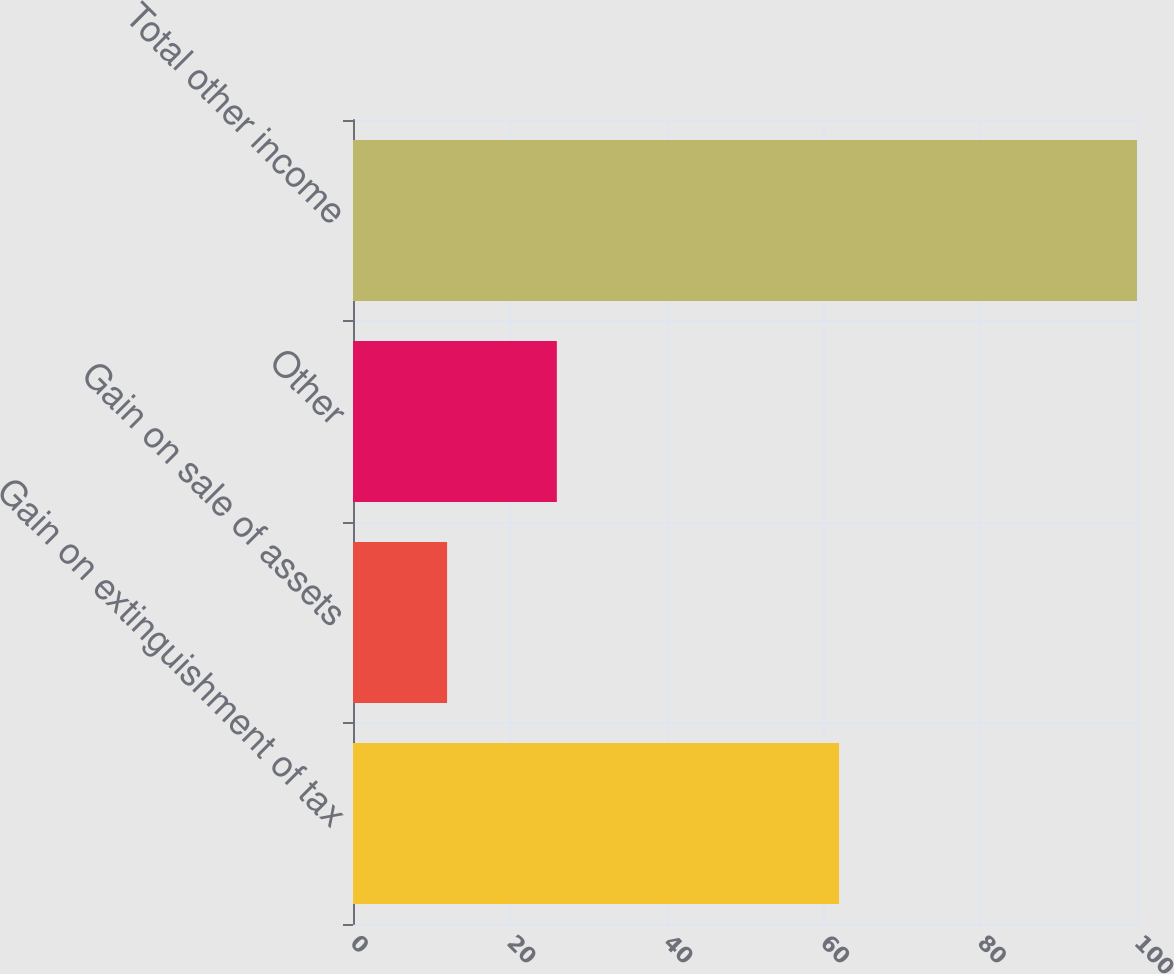Convert chart. <chart><loc_0><loc_0><loc_500><loc_500><bar_chart><fcel>Gain on extinguishment of tax<fcel>Gain on sale of assets<fcel>Other<fcel>Total other income<nl><fcel>62<fcel>12<fcel>26<fcel>100<nl></chart> 